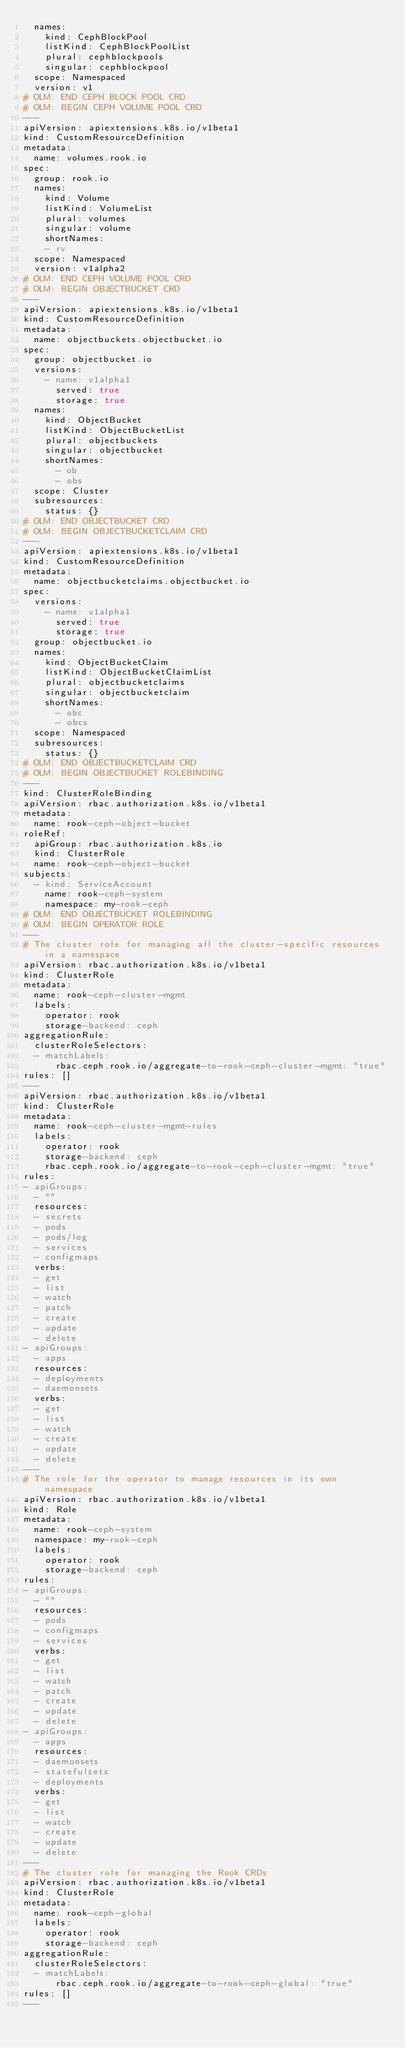Convert code to text. <code><loc_0><loc_0><loc_500><loc_500><_YAML_>  names:
    kind: CephBlockPool
    listKind: CephBlockPoolList
    plural: cephblockpools
    singular: cephblockpool
  scope: Namespaced
  version: v1
# OLM: END CEPH BLOCK POOL CRD
# OLM: BEGIN CEPH VOLUME POOL CRD
---
apiVersion: apiextensions.k8s.io/v1beta1
kind: CustomResourceDefinition
metadata:
  name: volumes.rook.io
spec:
  group: rook.io
  names:
    kind: Volume
    listKind: VolumeList
    plural: volumes
    singular: volume
    shortNames:
    - rv
  scope: Namespaced
  version: v1alpha2
# OLM: END CEPH VOLUME POOL CRD
# OLM: BEGIN OBJECTBUCKET CRD
---
apiVersion: apiextensions.k8s.io/v1beta1
kind: CustomResourceDefinition
metadata:
  name: objectbuckets.objectbucket.io
spec:
  group: objectbucket.io
  versions:
    - name: v1alpha1
      served: true
      storage: true
  names:
    kind: ObjectBucket
    listKind: ObjectBucketList
    plural: objectbuckets
    singular: objectbucket
    shortNames:
      - ob
      - obs
  scope: Cluster
  subresources:
    status: {}
# OLM: END OBJECTBUCKET CRD
# OLM: BEGIN OBJECTBUCKETCLAIM CRD
---
apiVersion: apiextensions.k8s.io/v1beta1
kind: CustomResourceDefinition
metadata:
  name: objectbucketclaims.objectbucket.io
spec:
  versions:
    - name: v1alpha1
      served: true
      storage: true
  group: objectbucket.io
  names:
    kind: ObjectBucketClaim
    listKind: ObjectBucketClaimList
    plural: objectbucketclaims
    singular: objectbucketclaim
    shortNames:
      - obc
      - obcs
  scope: Namespaced
  subresources:
    status: {}
# OLM: END OBJECTBUCKETCLAIM CRD
# OLM: BEGIN OBJECTBUCKET ROLEBINDING
---
kind: ClusterRoleBinding
apiVersion: rbac.authorization.k8s.io/v1beta1
metadata:
  name: rook-ceph-object-bucket
roleRef:
  apiGroup: rbac.authorization.k8s.io
  kind: ClusterRole
  name: rook-ceph-object-bucket
subjects:
  - kind: ServiceAccount
    name: rook-ceph-system
    namespace: my-rook-ceph
# OLM: END OBJECTBUCKET ROLEBINDING
# OLM: BEGIN OPERATOR ROLE
---
# The cluster role for managing all the cluster-specific resources in a namespace
apiVersion: rbac.authorization.k8s.io/v1beta1
kind: ClusterRole
metadata:
  name: rook-ceph-cluster-mgmt
  labels:
    operator: rook
    storage-backend: ceph
aggregationRule:
  clusterRoleSelectors:
  - matchLabels:
      rbac.ceph.rook.io/aggregate-to-rook-ceph-cluster-mgmt: "true"
rules: []
---
apiVersion: rbac.authorization.k8s.io/v1beta1
kind: ClusterRole
metadata:
  name: rook-ceph-cluster-mgmt-rules
  labels:
    operator: rook
    storage-backend: ceph
    rbac.ceph.rook.io/aggregate-to-rook-ceph-cluster-mgmt: "true"
rules:
- apiGroups:
  - ""
  resources:
  - secrets
  - pods
  - pods/log
  - services
  - configmaps
  verbs:
  - get
  - list
  - watch
  - patch
  - create
  - update
  - delete
- apiGroups:
  - apps
  resources:
  - deployments
  - daemonsets
  verbs:
  - get
  - list
  - watch
  - create
  - update
  - delete
---
# The role for the operator to manage resources in its own namespace
apiVersion: rbac.authorization.k8s.io/v1beta1
kind: Role
metadata:
  name: rook-ceph-system
  namespace: my-rook-ceph
  labels:
    operator: rook
    storage-backend: ceph
rules:
- apiGroups:
  - ""
  resources:
  - pods
  - configmaps
  - services
  verbs:
  - get
  - list
  - watch
  - patch
  - create
  - update
  - delete
- apiGroups:
  - apps
  resources:
  - daemonsets
  - statefulsets
  - deployments
  verbs:
  - get
  - list
  - watch
  - create
  - update
  - delete
---
# The cluster role for managing the Rook CRDs
apiVersion: rbac.authorization.k8s.io/v1beta1
kind: ClusterRole
metadata:
  name: rook-ceph-global
  labels:
    operator: rook
    storage-backend: ceph
aggregationRule:
  clusterRoleSelectors:
  - matchLabels:
      rbac.ceph.rook.io/aggregate-to-rook-ceph-global: "true"
rules: []
---</code> 